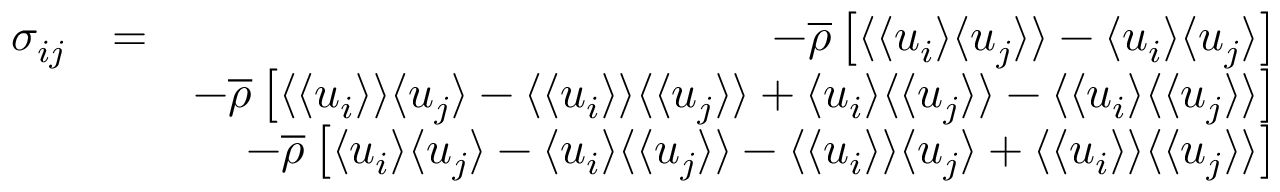Convert formula to latex. <formula><loc_0><loc_0><loc_500><loc_500>\begin{array} { r l r } { \sigma _ { i j } } & { = } & { - \overline { \rho } \left [ \langle { \langle u _ { i } \rangle \langle u _ { j } \rangle } \rangle - \langle u _ { i } \rangle \langle u _ { j } \rangle \right ] } \\ & { - \overline { \rho } \left [ \langle \langle u _ { i } \rangle \rangle \langle u _ { j } \rangle - \langle \langle u _ { i } \rangle \rangle \langle \langle u _ { j } \rangle \rangle + \langle u _ { i } \rangle \langle \langle u _ { j } \rangle \rangle - \langle \langle u _ { i } \rangle \langle \langle u _ { j } \rangle \rangle \right ] } \\ & { - \overline { \rho } \left [ \langle u _ { i } \rangle \langle u _ { j } \rangle - \langle u _ { i } \rangle \langle \langle u _ { j } \rangle \rangle - \langle \langle u _ { i } \rangle \rangle \langle u _ { j } \rangle + \langle \langle u _ { i } \rangle \rangle \langle \langle u _ { j } \rangle \rangle \right ] } \end{array}</formula> 